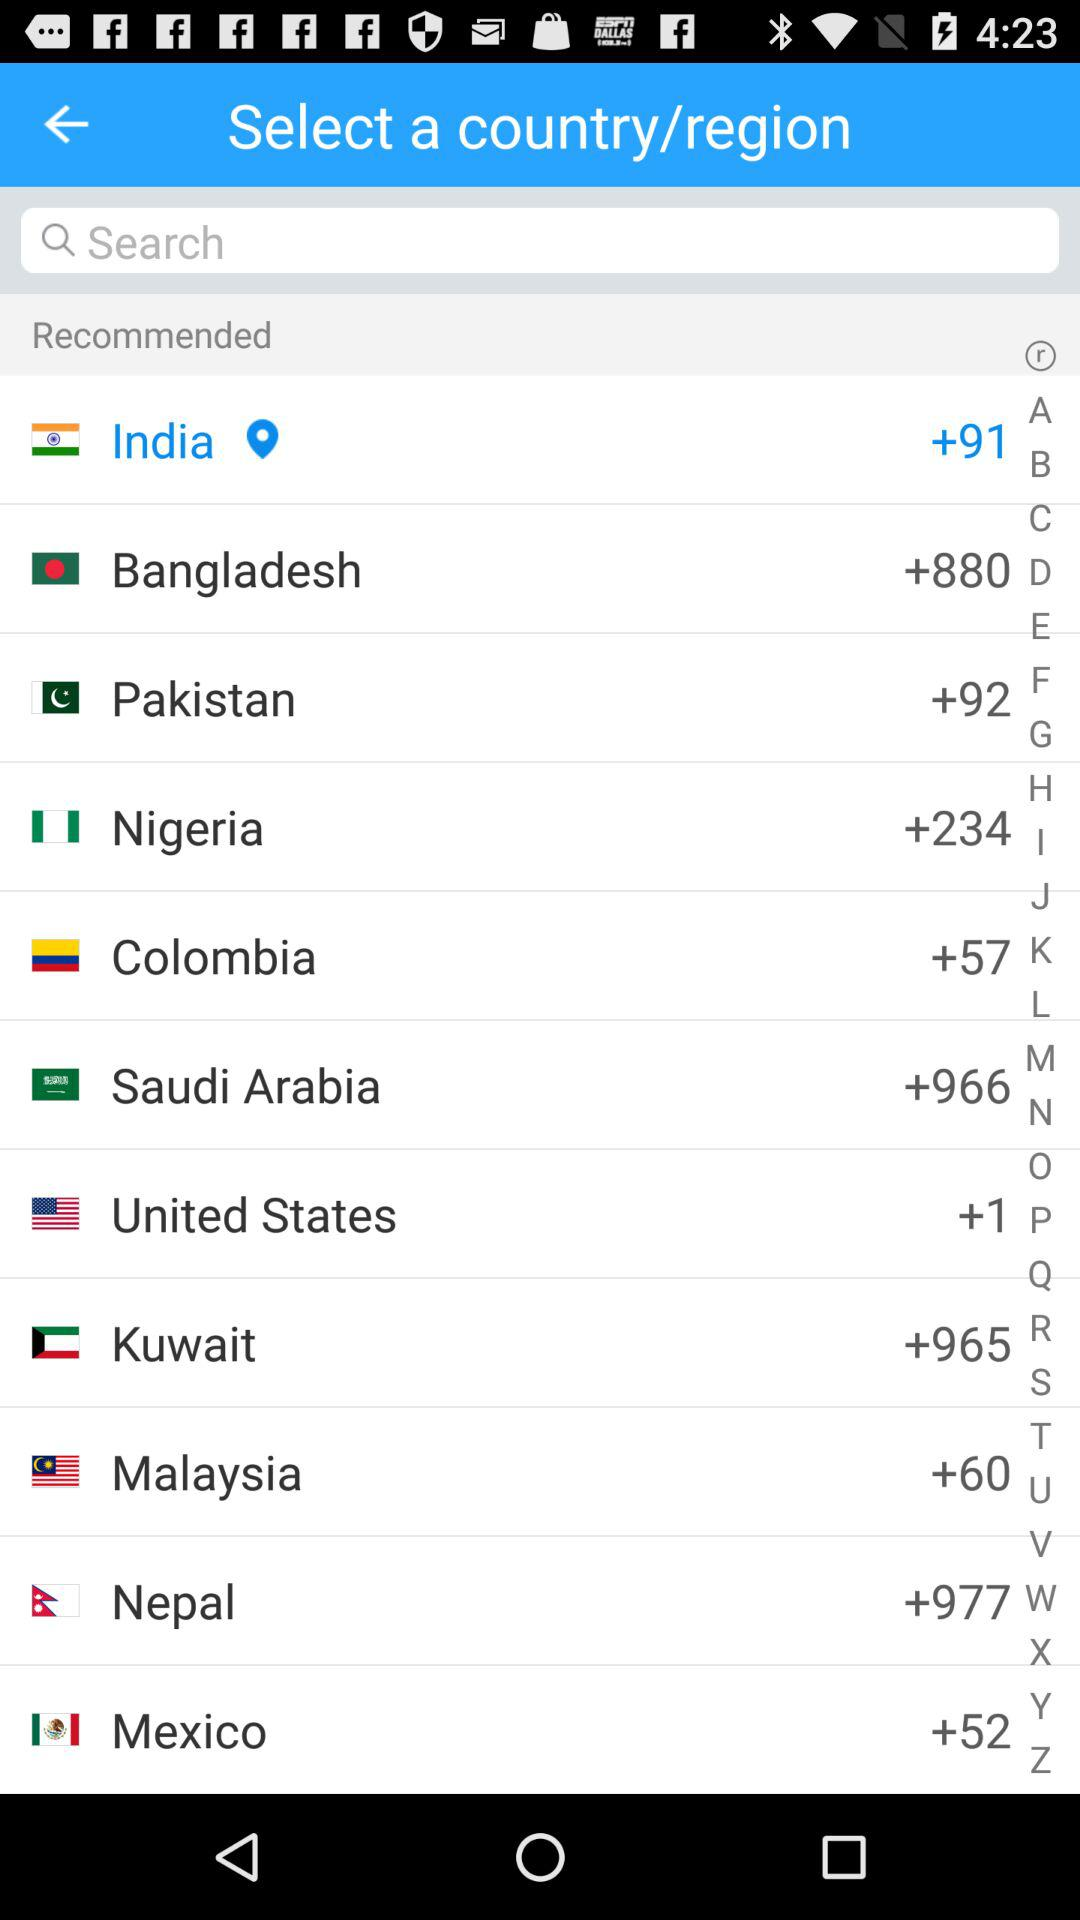What is the country code of India? The country code of India is +91. 